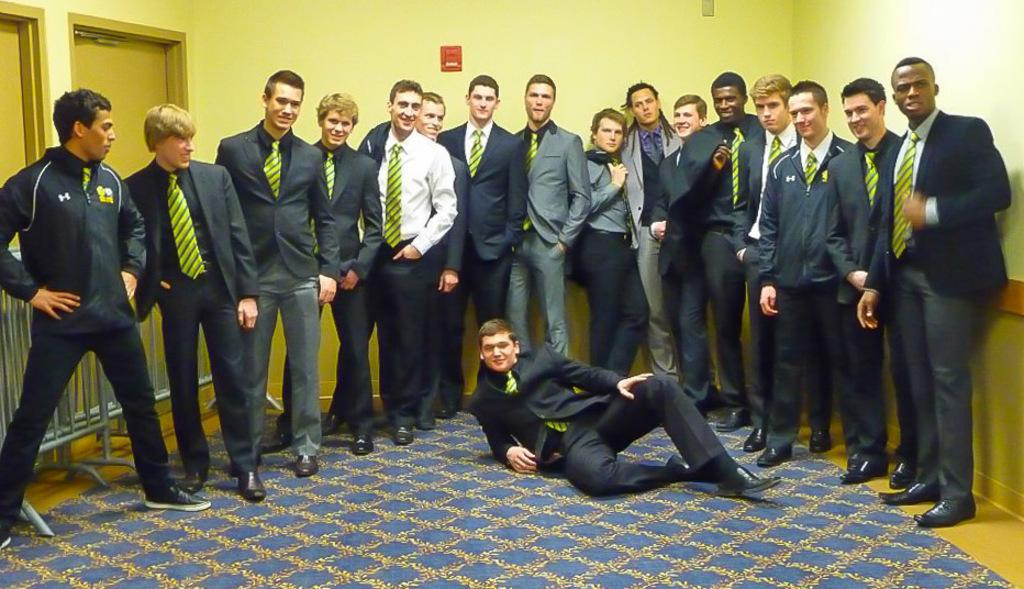Who is present in the image? There are people in the image. What are the people wearing? The people are wearing suits. What type of flooring is visible in the image? There is a floor with a carpet in the image. What can be seen in the background of the image? There is a wall in the background of the image. What architectural feature is present in the image? There is a fence in the image. What type of opening is visible in the image? There are doors in the image. What type of basketball game is being played in the image? There is no basketball game present in the image. What class is being taught in the image? There is no class or teaching activity depicted in the image. 